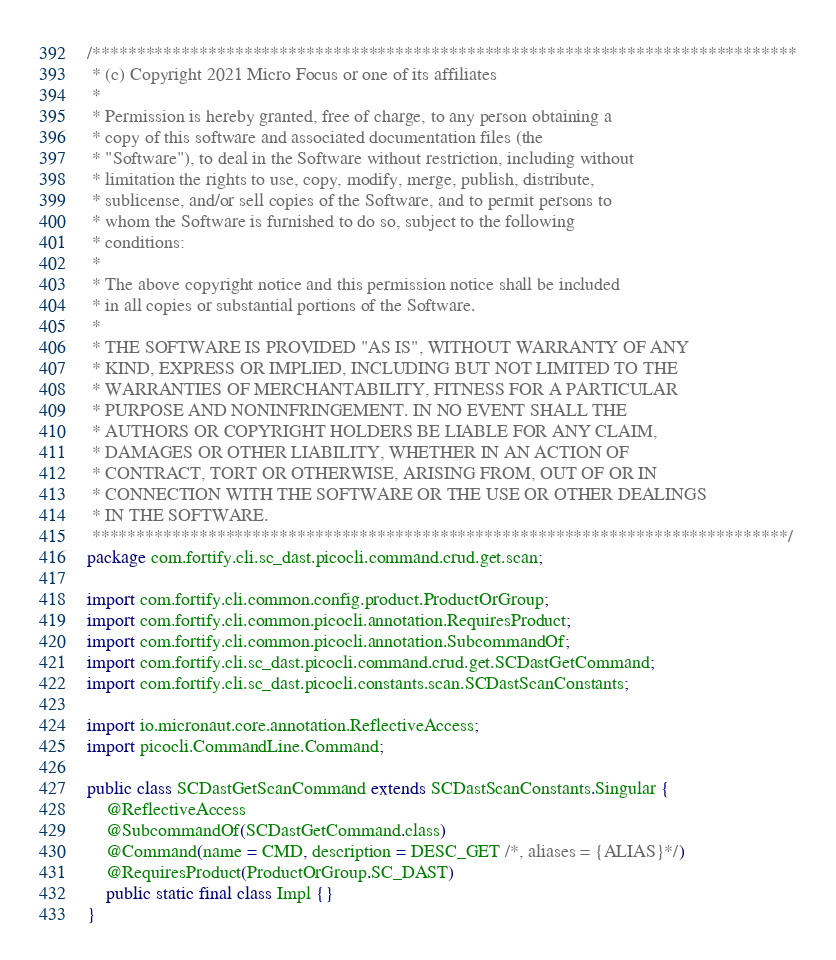Convert code to text. <code><loc_0><loc_0><loc_500><loc_500><_Java_>/*******************************************************************************
 * (c) Copyright 2021 Micro Focus or one of its affiliates
 *
 * Permission is hereby granted, free of charge, to any person obtaining a 
 * copy of this software and associated documentation files (the 
 * "Software"), to deal in the Software without restriction, including without 
 * limitation the rights to use, copy, modify, merge, publish, distribute, 
 * sublicense, and/or sell copies of the Software, and to permit persons to 
 * whom the Software is furnished to do so, subject to the following 
 * conditions:
 * 
 * The above copyright notice and this permission notice shall be included 
 * in all copies or substantial portions of the Software.
 * 
 * THE SOFTWARE IS PROVIDED "AS IS", WITHOUT WARRANTY OF ANY 
 * KIND, EXPRESS OR IMPLIED, INCLUDING BUT NOT LIMITED TO THE 
 * WARRANTIES OF MERCHANTABILITY, FITNESS FOR A PARTICULAR 
 * PURPOSE AND NONINFRINGEMENT. IN NO EVENT SHALL THE 
 * AUTHORS OR COPYRIGHT HOLDERS BE LIABLE FOR ANY CLAIM, 
 * DAMAGES OR OTHER LIABILITY, WHETHER IN AN ACTION OF 
 * CONTRACT, TORT OR OTHERWISE, ARISING FROM, OUT OF OR IN 
 * CONNECTION WITH THE SOFTWARE OR THE USE OR OTHER DEALINGS 
 * IN THE SOFTWARE.
 ******************************************************************************/
package com.fortify.cli.sc_dast.picocli.command.crud.get.scan;

import com.fortify.cli.common.config.product.ProductOrGroup;
import com.fortify.cli.common.picocli.annotation.RequiresProduct;
import com.fortify.cli.common.picocli.annotation.SubcommandOf;
import com.fortify.cli.sc_dast.picocli.command.crud.get.SCDastGetCommand;
import com.fortify.cli.sc_dast.picocli.constants.scan.SCDastScanConstants;

import io.micronaut.core.annotation.ReflectiveAccess;
import picocli.CommandLine.Command;

public class SCDastGetScanCommand extends SCDastScanConstants.Singular {
	@ReflectiveAccess
	@SubcommandOf(SCDastGetCommand.class)
	@Command(name = CMD, description = DESC_GET /*, aliases = {ALIAS}*/)
	@RequiresProduct(ProductOrGroup.SC_DAST)
	public static final class Impl {}
}
</code> 